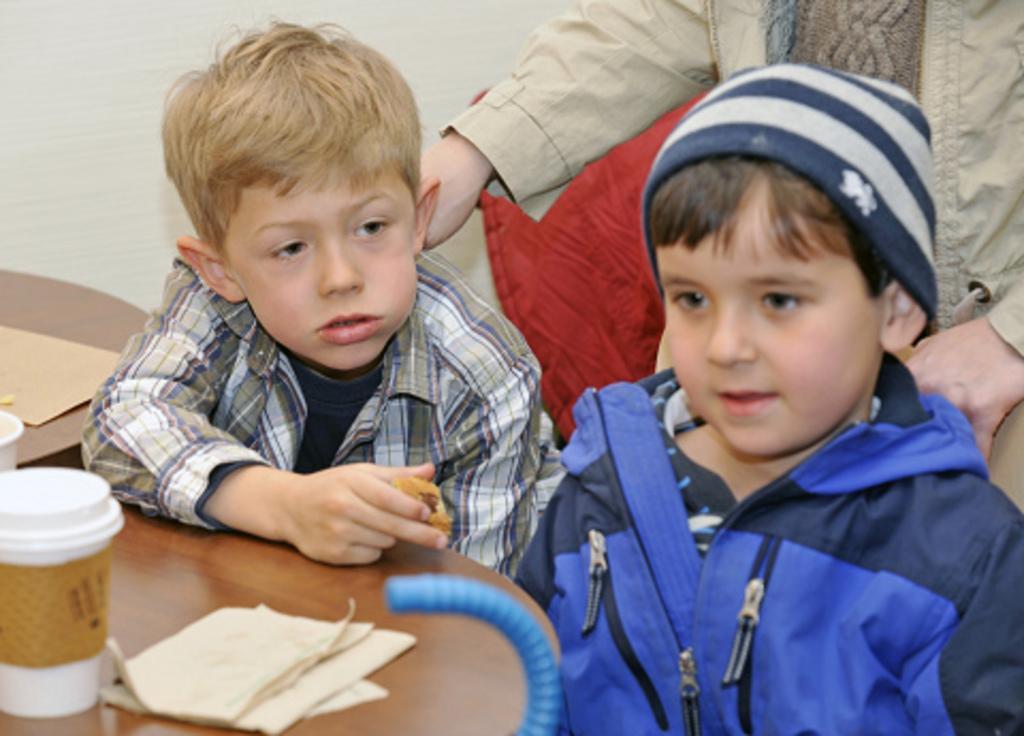Can you describe this image briefly? I can see in this image to two boys are sitting in front of a table and a person standing behind these boys. On the table we have few objects on it. 